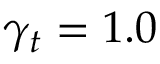<formula> <loc_0><loc_0><loc_500><loc_500>\gamma _ { t } = 1 . 0</formula> 